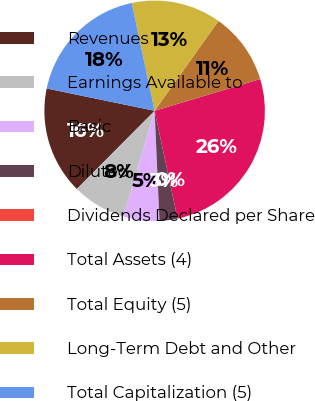Convert chart. <chart><loc_0><loc_0><loc_500><loc_500><pie_chart><fcel>Revenues<fcel>Earnings Available to<fcel>Basic<fcel>Diluted<fcel>Dividends Declared per Share<fcel>Total Assets (4)<fcel>Total Equity (5)<fcel>Long-Term Debt and Other<fcel>Total Capitalization (5)<nl><fcel>15.79%<fcel>7.9%<fcel>5.26%<fcel>2.63%<fcel>0.0%<fcel>26.31%<fcel>10.53%<fcel>13.16%<fcel>18.42%<nl></chart> 